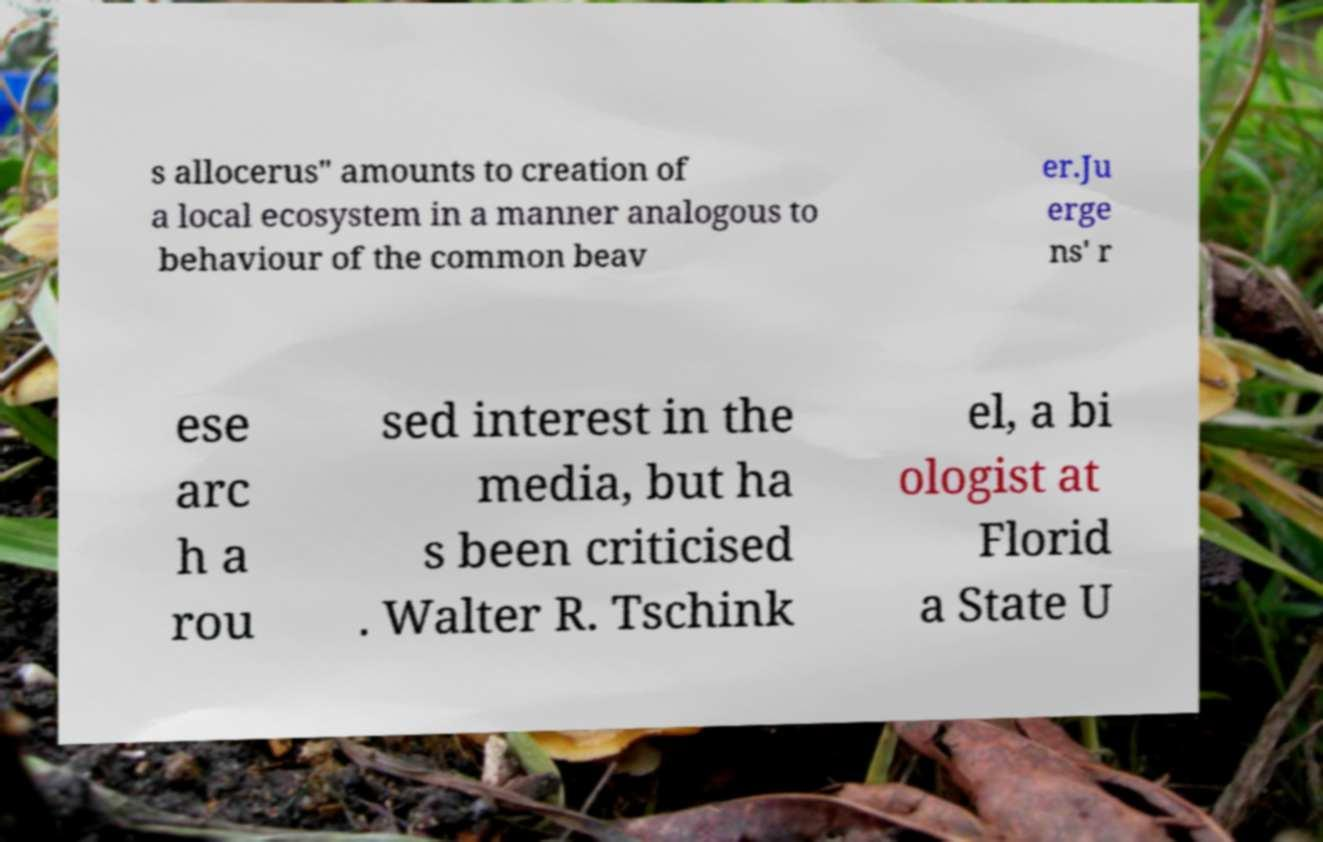Can you accurately transcribe the text from the provided image for me? s allocerus" amounts to creation of a local ecosystem in a manner analogous to behaviour of the common beav er.Ju erge ns' r ese arc h a rou sed interest in the media, but ha s been criticised . Walter R. Tschink el, a bi ologist at Florid a State U 